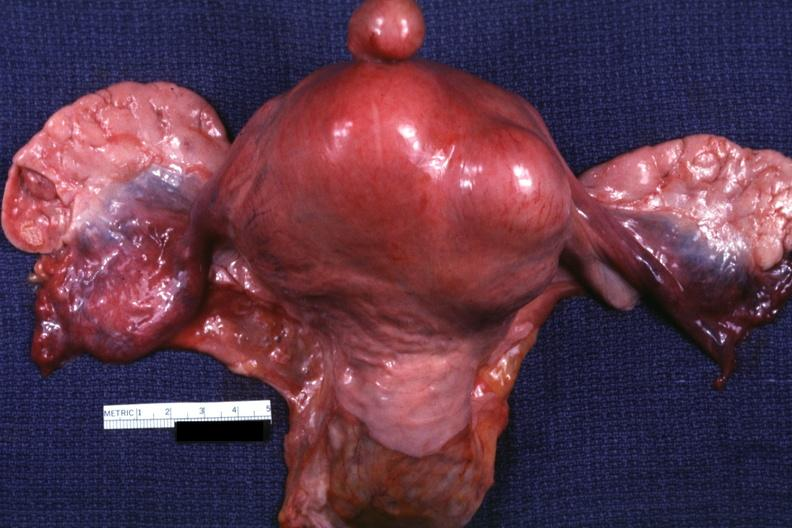what is present?
Answer the question using a single word or phrase. Female reproductive 